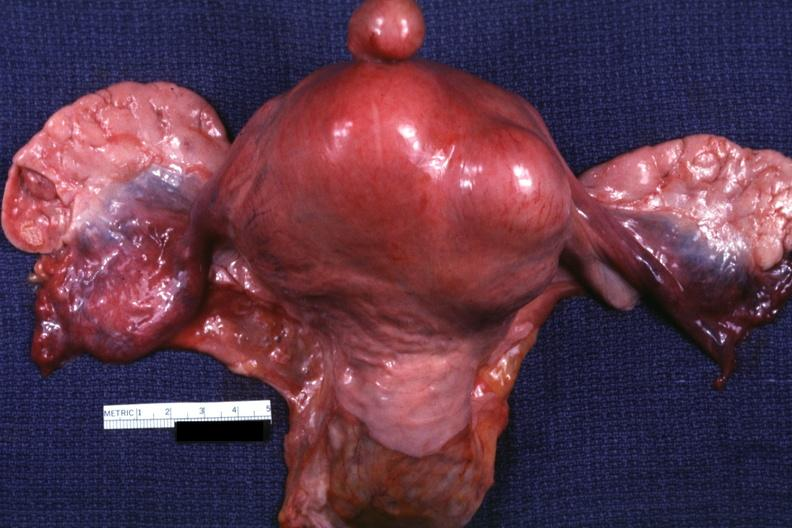what is present?
Answer the question using a single word or phrase. Female reproductive 